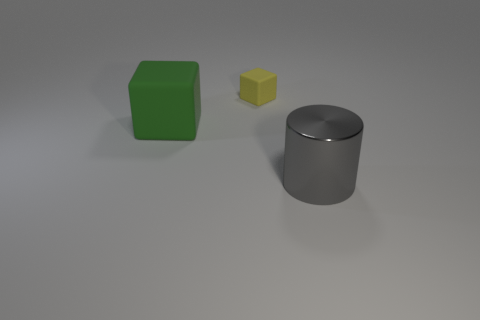Are there any other things that are the same size as the yellow rubber block?
Your response must be concise. No. There is a large thing that is behind the large metal thing; how many yellow rubber objects are behind it?
Ensure brevity in your answer.  1. What shape is the rubber thing that is to the right of the large object on the left side of the thing on the right side of the tiny object?
Ensure brevity in your answer.  Cube. How many things are tiny yellow cubes or green objects?
Your answer should be compact. 2. What is the color of the other thing that is the same size as the gray object?
Offer a very short reply. Green. There is a green rubber object; is its shape the same as the rubber object right of the green cube?
Keep it short and to the point. Yes. How many objects are big objects that are left of the gray shiny object or blocks that are behind the green object?
Offer a terse response. 2. There is a large thing behind the large gray cylinder; what shape is it?
Keep it short and to the point. Cube. There is a thing in front of the large green rubber thing; is its shape the same as the yellow matte thing?
Provide a short and direct response. No. How many things are either objects that are behind the metallic thing or gray shiny things?
Give a very brief answer. 3. 